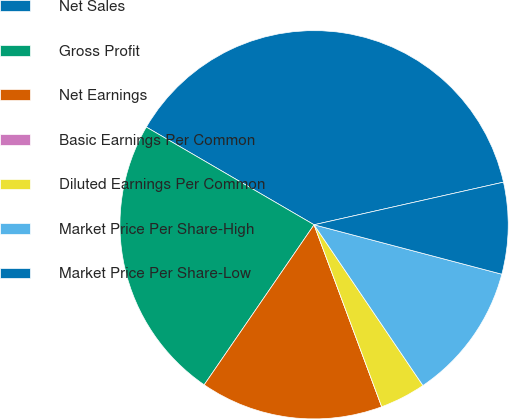Convert chart. <chart><loc_0><loc_0><loc_500><loc_500><pie_chart><fcel>Net Sales<fcel>Gross Profit<fcel>Net Earnings<fcel>Basic Earnings Per Common<fcel>Diluted Earnings Per Common<fcel>Market Price Per Share-High<fcel>Market Price Per Share-Low<nl><fcel>38.09%<fcel>23.82%<fcel>15.24%<fcel>0.0%<fcel>3.81%<fcel>11.43%<fcel>7.62%<nl></chart> 